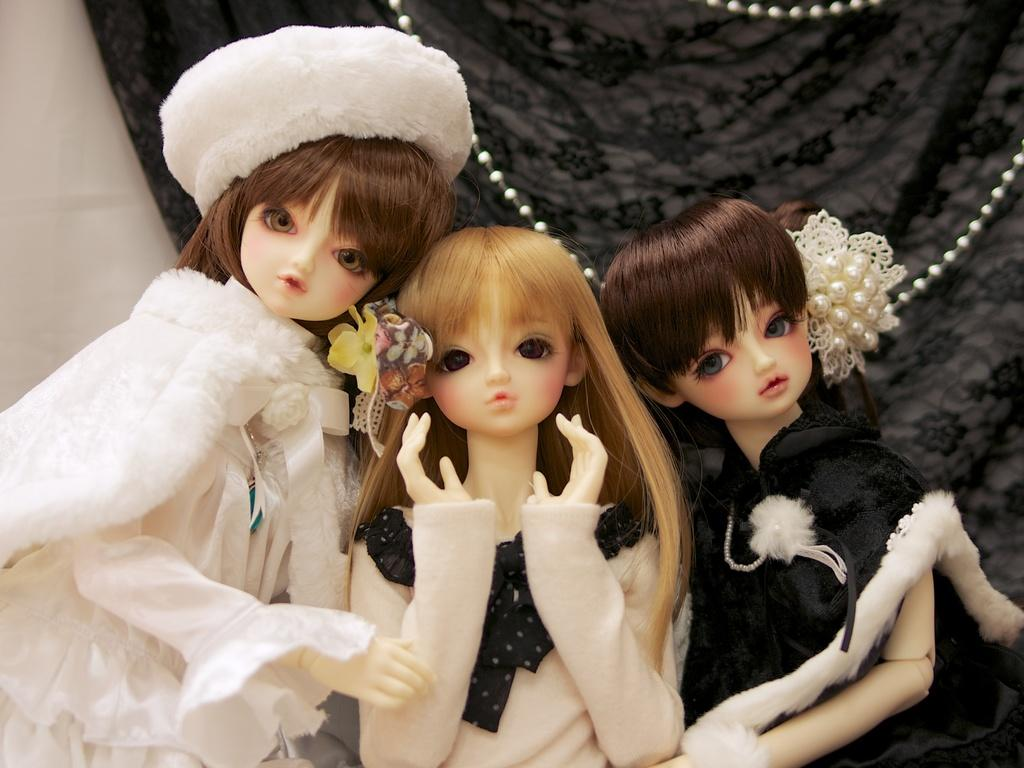What objects are in the front of the image? There are dolls in the front of the image. What can be seen in the background of the image? There is a cloth in the background of the image. What is the color of the cloth? The cloth is black in color. What is the name of the airplane in the image? There is no airplane present in the image. Can you tell me if the dolls in the image have received approval for a certain activity? The image does not provide information about the dolls receiving approval for any activity. 